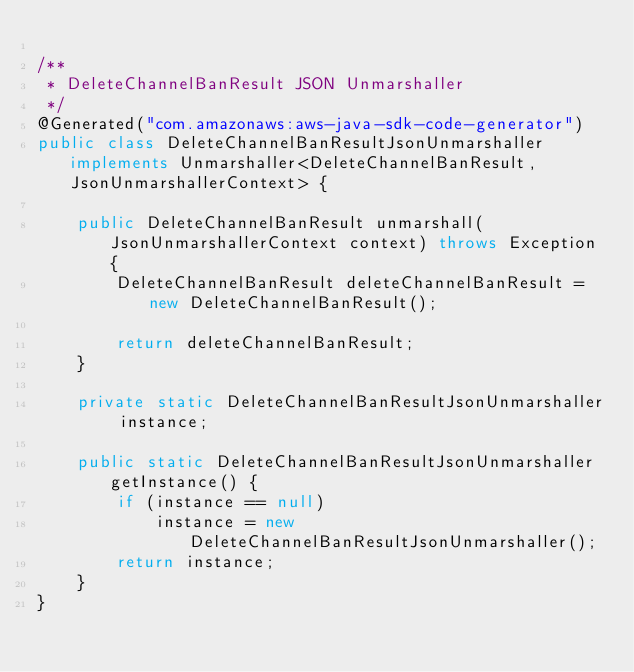Convert code to text. <code><loc_0><loc_0><loc_500><loc_500><_Java_>
/**
 * DeleteChannelBanResult JSON Unmarshaller
 */
@Generated("com.amazonaws:aws-java-sdk-code-generator")
public class DeleteChannelBanResultJsonUnmarshaller implements Unmarshaller<DeleteChannelBanResult, JsonUnmarshallerContext> {

    public DeleteChannelBanResult unmarshall(JsonUnmarshallerContext context) throws Exception {
        DeleteChannelBanResult deleteChannelBanResult = new DeleteChannelBanResult();

        return deleteChannelBanResult;
    }

    private static DeleteChannelBanResultJsonUnmarshaller instance;

    public static DeleteChannelBanResultJsonUnmarshaller getInstance() {
        if (instance == null)
            instance = new DeleteChannelBanResultJsonUnmarshaller();
        return instance;
    }
}
</code> 